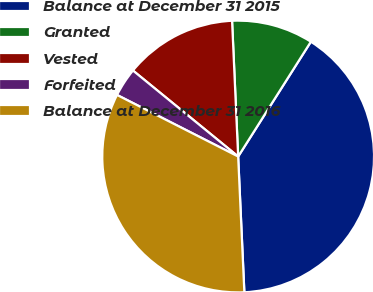Convert chart to OTSL. <chart><loc_0><loc_0><loc_500><loc_500><pie_chart><fcel>Balance at December 31 2015<fcel>Granted<fcel>Vested<fcel>Forfeited<fcel>Balance at December 31 2016<nl><fcel>40.29%<fcel>9.7%<fcel>13.38%<fcel>3.42%<fcel>33.21%<nl></chart> 